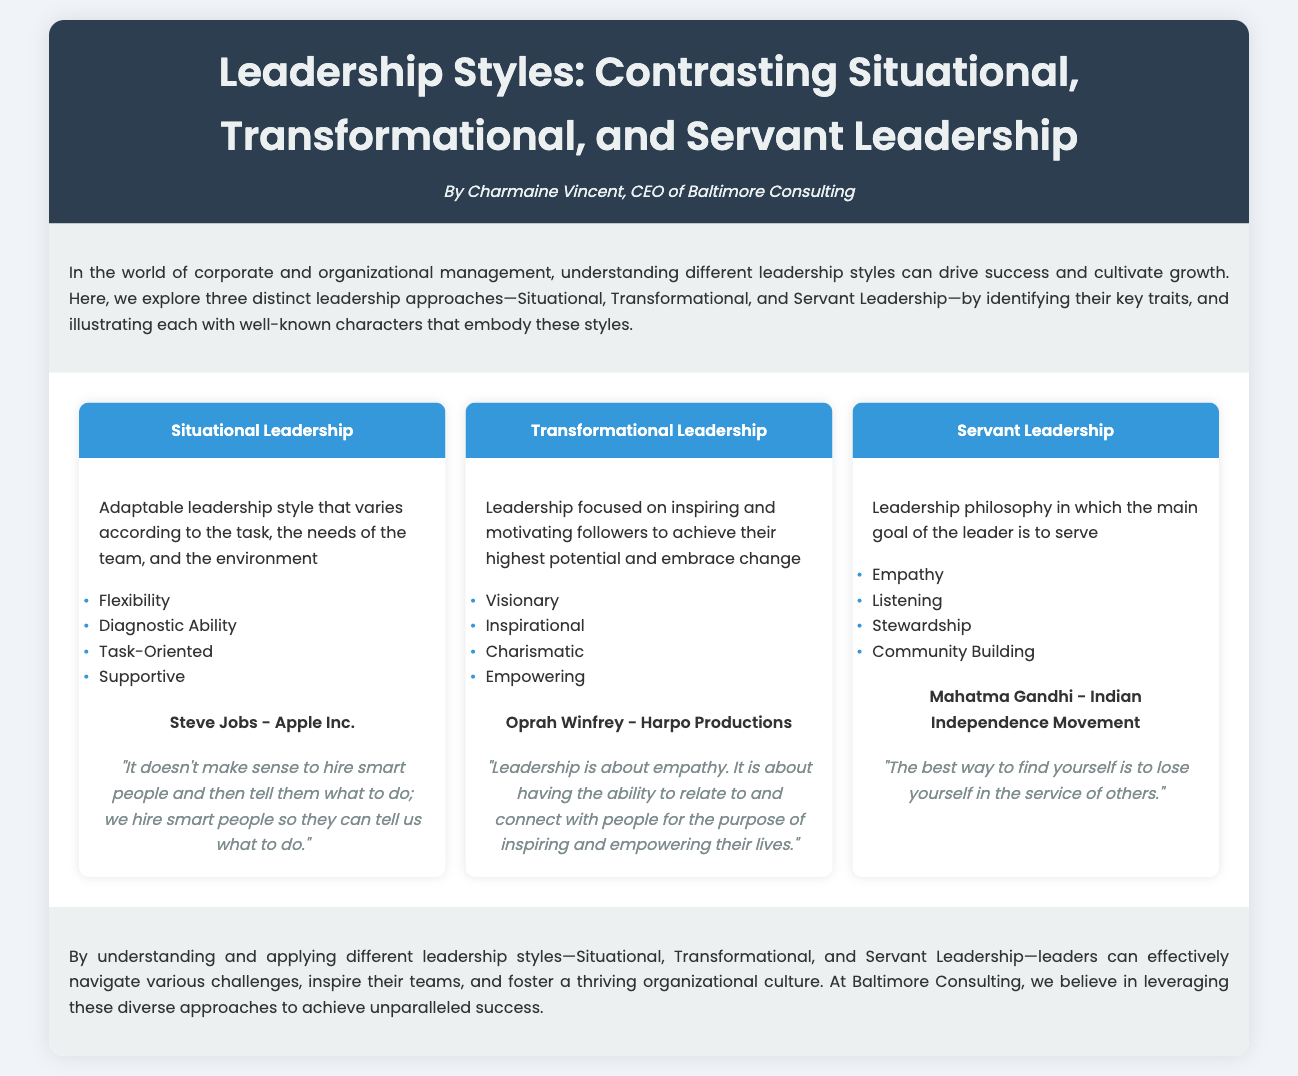what are the three leadership styles compared in the document? The document lists Situational, Transformational, and Servant Leadership as the three styles being compared.
Answer: Situational, Transformational, Servant Leadership who is associated with Situational Leadership? The character associated with Situational Leadership in the document is Steve Jobs.
Answer: Steve Jobs which leadership style focuses on community building? The traits mentioned for Servant Leadership include community building.
Answer: Servant Leadership what is one key trait of Transformational Leadership? One of the key traits listed for Transformational Leadership is "Visionary."
Answer: Visionary what quote is attributed to Mahatma Gandhi? The document includes the quote "The best way to find yourself is to lose yourself in the service of others." attributed to Mahatma Gandhi.
Answer: "The best way to find yourself is to lose yourself in the service of others." how many traits are listed for Situational Leadership? The document lists four traits for Situational Leadership.
Answer: Four which leadership style is described as adaptable? The document describes Situational Leadership as an adaptable leadership style.
Answer: Situational Leadership who is associated with Transformational Leadership? The character depicted for Transformational Leadership is Oprah Winfrey.
Answer: Oprah Winfrey 